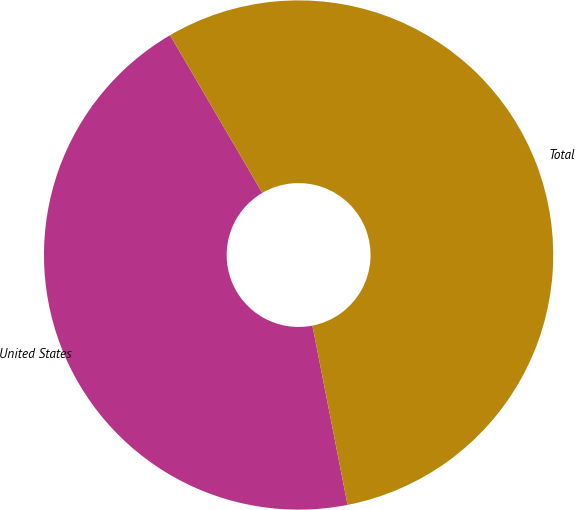<chart> <loc_0><loc_0><loc_500><loc_500><pie_chart><fcel>United States<fcel>Total<nl><fcel>44.66%<fcel>55.34%<nl></chart> 